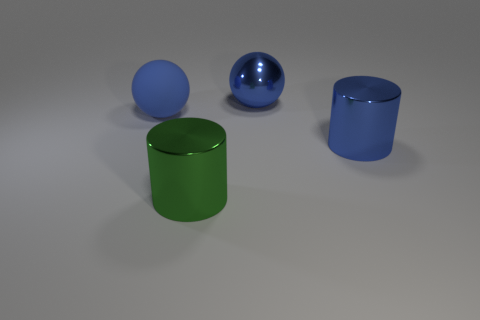Add 4 metallic spheres. How many objects exist? 8 Add 1 blue rubber things. How many blue rubber things are left? 2 Add 4 red matte balls. How many red matte balls exist? 4 Subtract 0 green cubes. How many objects are left? 4 Subtract 2 balls. How many balls are left? 0 Subtract all blue cylinders. Subtract all brown balls. How many cylinders are left? 1 Subtract all metal objects. Subtract all green metal cylinders. How many objects are left? 0 